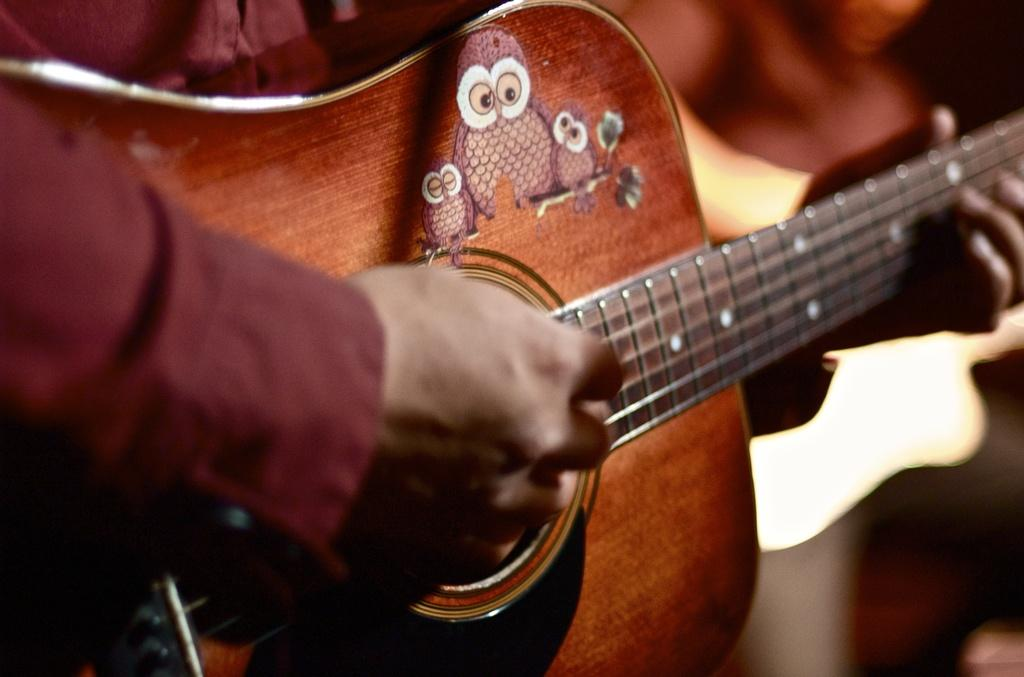What is the main subject of the image? There is a person in the image. What is the person holding in the image? The person is holding a music instrument. Can you describe the music instrument? The music instrument is yellow in color. What is the person doing with the music instrument? The person is playing the music instrument. How much money is being exchanged for the grain in the image? There is no money or grain present in the image; it features a person playing a yellow music instrument. 